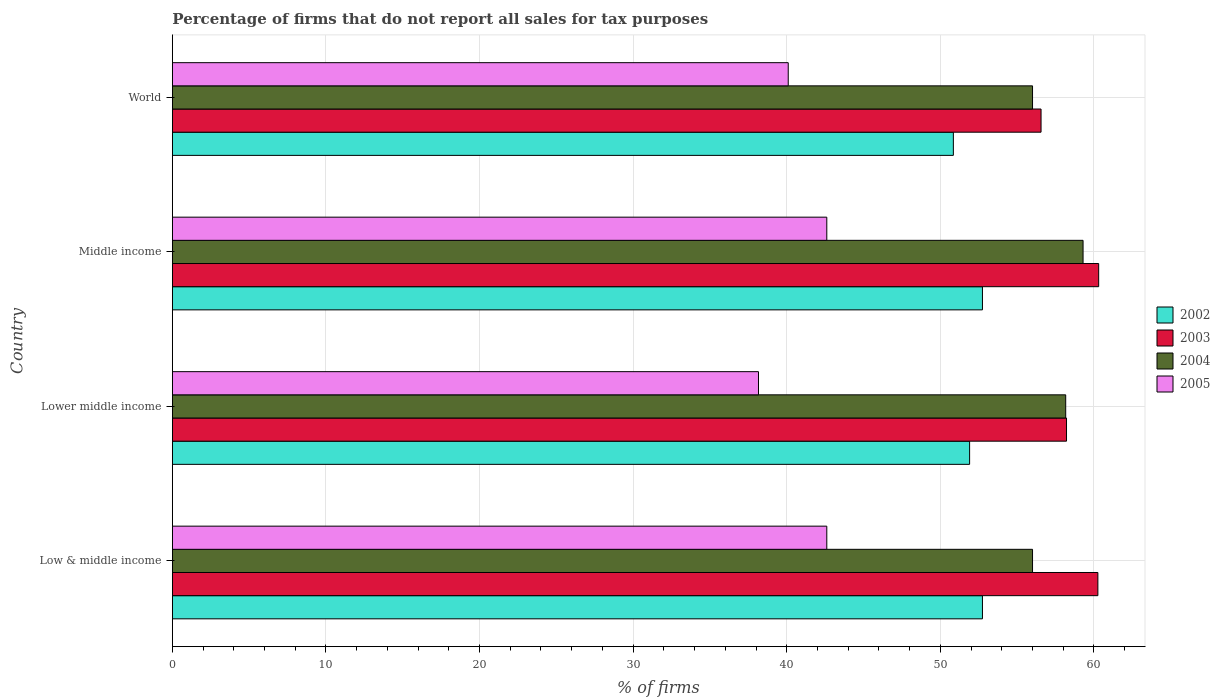How many different coloured bars are there?
Offer a terse response. 4. How many bars are there on the 4th tick from the top?
Keep it short and to the point. 4. What is the percentage of firms that do not report all sales for tax purposes in 2005 in Low & middle income?
Provide a short and direct response. 42.61. Across all countries, what is the maximum percentage of firms that do not report all sales for tax purposes in 2003?
Your response must be concise. 60.31. Across all countries, what is the minimum percentage of firms that do not report all sales for tax purposes in 2005?
Offer a terse response. 38.16. In which country was the percentage of firms that do not report all sales for tax purposes in 2005 minimum?
Offer a very short reply. Lower middle income. What is the total percentage of firms that do not report all sales for tax purposes in 2005 in the graph?
Provide a succinct answer. 163.48. What is the difference between the percentage of firms that do not report all sales for tax purposes in 2004 in Low & middle income and that in Lower middle income?
Keep it short and to the point. -2.16. What is the difference between the percentage of firms that do not report all sales for tax purposes in 2004 in Middle income and the percentage of firms that do not report all sales for tax purposes in 2002 in Low & middle income?
Provide a succinct answer. 6.55. What is the average percentage of firms that do not report all sales for tax purposes in 2002 per country?
Make the answer very short. 52.06. What is the difference between the percentage of firms that do not report all sales for tax purposes in 2004 and percentage of firms that do not report all sales for tax purposes in 2005 in Middle income?
Provide a succinct answer. 16.69. What is the ratio of the percentage of firms that do not report all sales for tax purposes in 2004 in Lower middle income to that in World?
Your answer should be very brief. 1.04. What is the difference between the highest and the second highest percentage of firms that do not report all sales for tax purposes in 2002?
Give a very brief answer. 0. What is the difference between the highest and the lowest percentage of firms that do not report all sales for tax purposes in 2004?
Your answer should be compact. 3.29. What does the 3rd bar from the top in Lower middle income represents?
Provide a short and direct response. 2003. What does the 3rd bar from the bottom in Lower middle income represents?
Make the answer very short. 2004. How many bars are there?
Make the answer very short. 16. Are all the bars in the graph horizontal?
Offer a terse response. Yes. Are the values on the major ticks of X-axis written in scientific E-notation?
Provide a short and direct response. No. Does the graph contain any zero values?
Keep it short and to the point. No. What is the title of the graph?
Your answer should be compact. Percentage of firms that do not report all sales for tax purposes. Does "1968" appear as one of the legend labels in the graph?
Provide a short and direct response. No. What is the label or title of the X-axis?
Keep it short and to the point. % of firms. What is the label or title of the Y-axis?
Make the answer very short. Country. What is the % of firms of 2002 in Low & middle income?
Keep it short and to the point. 52.75. What is the % of firms in 2003 in Low & middle income?
Your answer should be very brief. 60.26. What is the % of firms of 2004 in Low & middle income?
Your response must be concise. 56.01. What is the % of firms in 2005 in Low & middle income?
Your answer should be very brief. 42.61. What is the % of firms of 2002 in Lower middle income?
Offer a terse response. 51.91. What is the % of firms in 2003 in Lower middle income?
Offer a very short reply. 58.22. What is the % of firms of 2004 in Lower middle income?
Your response must be concise. 58.16. What is the % of firms of 2005 in Lower middle income?
Ensure brevity in your answer.  38.16. What is the % of firms of 2002 in Middle income?
Keep it short and to the point. 52.75. What is the % of firms in 2003 in Middle income?
Your answer should be very brief. 60.31. What is the % of firms in 2004 in Middle income?
Your response must be concise. 59.3. What is the % of firms in 2005 in Middle income?
Ensure brevity in your answer.  42.61. What is the % of firms in 2002 in World?
Offer a very short reply. 50.85. What is the % of firms of 2003 in World?
Provide a short and direct response. 56.56. What is the % of firms in 2004 in World?
Offer a very short reply. 56.01. What is the % of firms of 2005 in World?
Provide a succinct answer. 40.1. Across all countries, what is the maximum % of firms of 2002?
Your answer should be very brief. 52.75. Across all countries, what is the maximum % of firms of 2003?
Give a very brief answer. 60.31. Across all countries, what is the maximum % of firms in 2004?
Give a very brief answer. 59.3. Across all countries, what is the maximum % of firms in 2005?
Give a very brief answer. 42.61. Across all countries, what is the minimum % of firms of 2002?
Give a very brief answer. 50.85. Across all countries, what is the minimum % of firms in 2003?
Offer a very short reply. 56.56. Across all countries, what is the minimum % of firms of 2004?
Make the answer very short. 56.01. Across all countries, what is the minimum % of firms of 2005?
Give a very brief answer. 38.16. What is the total % of firms in 2002 in the graph?
Keep it short and to the point. 208.25. What is the total % of firms of 2003 in the graph?
Your answer should be compact. 235.35. What is the total % of firms of 2004 in the graph?
Your answer should be very brief. 229.47. What is the total % of firms in 2005 in the graph?
Give a very brief answer. 163.48. What is the difference between the % of firms of 2002 in Low & middle income and that in Lower middle income?
Your answer should be very brief. 0.84. What is the difference between the % of firms in 2003 in Low & middle income and that in Lower middle income?
Keep it short and to the point. 2.04. What is the difference between the % of firms of 2004 in Low & middle income and that in Lower middle income?
Provide a succinct answer. -2.16. What is the difference between the % of firms in 2005 in Low & middle income and that in Lower middle income?
Your answer should be very brief. 4.45. What is the difference between the % of firms of 2003 in Low & middle income and that in Middle income?
Your answer should be very brief. -0.05. What is the difference between the % of firms of 2004 in Low & middle income and that in Middle income?
Your answer should be very brief. -3.29. What is the difference between the % of firms in 2005 in Low & middle income and that in Middle income?
Offer a very short reply. 0. What is the difference between the % of firms of 2002 in Low & middle income and that in World?
Your answer should be very brief. 1.89. What is the difference between the % of firms of 2004 in Low & middle income and that in World?
Provide a succinct answer. 0. What is the difference between the % of firms in 2005 in Low & middle income and that in World?
Provide a succinct answer. 2.51. What is the difference between the % of firms in 2002 in Lower middle income and that in Middle income?
Your answer should be very brief. -0.84. What is the difference between the % of firms of 2003 in Lower middle income and that in Middle income?
Give a very brief answer. -2.09. What is the difference between the % of firms in 2004 in Lower middle income and that in Middle income?
Your answer should be very brief. -1.13. What is the difference between the % of firms of 2005 in Lower middle income and that in Middle income?
Your answer should be very brief. -4.45. What is the difference between the % of firms of 2002 in Lower middle income and that in World?
Your answer should be very brief. 1.06. What is the difference between the % of firms of 2003 in Lower middle income and that in World?
Offer a terse response. 1.66. What is the difference between the % of firms of 2004 in Lower middle income and that in World?
Make the answer very short. 2.16. What is the difference between the % of firms in 2005 in Lower middle income and that in World?
Your answer should be very brief. -1.94. What is the difference between the % of firms of 2002 in Middle income and that in World?
Your response must be concise. 1.89. What is the difference between the % of firms in 2003 in Middle income and that in World?
Provide a short and direct response. 3.75. What is the difference between the % of firms of 2004 in Middle income and that in World?
Provide a short and direct response. 3.29. What is the difference between the % of firms of 2005 in Middle income and that in World?
Ensure brevity in your answer.  2.51. What is the difference between the % of firms of 2002 in Low & middle income and the % of firms of 2003 in Lower middle income?
Your response must be concise. -5.47. What is the difference between the % of firms of 2002 in Low & middle income and the % of firms of 2004 in Lower middle income?
Provide a succinct answer. -5.42. What is the difference between the % of firms of 2002 in Low & middle income and the % of firms of 2005 in Lower middle income?
Ensure brevity in your answer.  14.58. What is the difference between the % of firms in 2003 in Low & middle income and the % of firms in 2004 in Lower middle income?
Ensure brevity in your answer.  2.1. What is the difference between the % of firms in 2003 in Low & middle income and the % of firms in 2005 in Lower middle income?
Offer a very short reply. 22.1. What is the difference between the % of firms of 2004 in Low & middle income and the % of firms of 2005 in Lower middle income?
Your response must be concise. 17.84. What is the difference between the % of firms of 2002 in Low & middle income and the % of firms of 2003 in Middle income?
Your answer should be compact. -7.57. What is the difference between the % of firms in 2002 in Low & middle income and the % of firms in 2004 in Middle income?
Offer a very short reply. -6.55. What is the difference between the % of firms of 2002 in Low & middle income and the % of firms of 2005 in Middle income?
Provide a succinct answer. 10.13. What is the difference between the % of firms of 2003 in Low & middle income and the % of firms of 2004 in Middle income?
Offer a very short reply. 0.96. What is the difference between the % of firms in 2003 in Low & middle income and the % of firms in 2005 in Middle income?
Offer a terse response. 17.65. What is the difference between the % of firms in 2004 in Low & middle income and the % of firms in 2005 in Middle income?
Keep it short and to the point. 13.39. What is the difference between the % of firms of 2002 in Low & middle income and the % of firms of 2003 in World?
Offer a terse response. -3.81. What is the difference between the % of firms in 2002 in Low & middle income and the % of firms in 2004 in World?
Your answer should be very brief. -3.26. What is the difference between the % of firms of 2002 in Low & middle income and the % of firms of 2005 in World?
Make the answer very short. 12.65. What is the difference between the % of firms of 2003 in Low & middle income and the % of firms of 2004 in World?
Offer a terse response. 4.25. What is the difference between the % of firms in 2003 in Low & middle income and the % of firms in 2005 in World?
Make the answer very short. 20.16. What is the difference between the % of firms in 2004 in Low & middle income and the % of firms in 2005 in World?
Make the answer very short. 15.91. What is the difference between the % of firms in 2002 in Lower middle income and the % of firms in 2003 in Middle income?
Ensure brevity in your answer.  -8.4. What is the difference between the % of firms in 2002 in Lower middle income and the % of firms in 2004 in Middle income?
Ensure brevity in your answer.  -7.39. What is the difference between the % of firms in 2002 in Lower middle income and the % of firms in 2005 in Middle income?
Give a very brief answer. 9.3. What is the difference between the % of firms of 2003 in Lower middle income and the % of firms of 2004 in Middle income?
Provide a succinct answer. -1.08. What is the difference between the % of firms in 2003 in Lower middle income and the % of firms in 2005 in Middle income?
Offer a terse response. 15.61. What is the difference between the % of firms in 2004 in Lower middle income and the % of firms in 2005 in Middle income?
Keep it short and to the point. 15.55. What is the difference between the % of firms of 2002 in Lower middle income and the % of firms of 2003 in World?
Provide a short and direct response. -4.65. What is the difference between the % of firms in 2002 in Lower middle income and the % of firms in 2004 in World?
Keep it short and to the point. -4.1. What is the difference between the % of firms of 2002 in Lower middle income and the % of firms of 2005 in World?
Your response must be concise. 11.81. What is the difference between the % of firms in 2003 in Lower middle income and the % of firms in 2004 in World?
Provide a succinct answer. 2.21. What is the difference between the % of firms in 2003 in Lower middle income and the % of firms in 2005 in World?
Ensure brevity in your answer.  18.12. What is the difference between the % of firms in 2004 in Lower middle income and the % of firms in 2005 in World?
Your response must be concise. 18.07. What is the difference between the % of firms in 2002 in Middle income and the % of firms in 2003 in World?
Provide a succinct answer. -3.81. What is the difference between the % of firms in 2002 in Middle income and the % of firms in 2004 in World?
Make the answer very short. -3.26. What is the difference between the % of firms of 2002 in Middle income and the % of firms of 2005 in World?
Your response must be concise. 12.65. What is the difference between the % of firms of 2003 in Middle income and the % of firms of 2004 in World?
Ensure brevity in your answer.  4.31. What is the difference between the % of firms of 2003 in Middle income and the % of firms of 2005 in World?
Make the answer very short. 20.21. What is the difference between the % of firms of 2004 in Middle income and the % of firms of 2005 in World?
Keep it short and to the point. 19.2. What is the average % of firms of 2002 per country?
Your response must be concise. 52.06. What is the average % of firms of 2003 per country?
Your response must be concise. 58.84. What is the average % of firms of 2004 per country?
Provide a short and direct response. 57.37. What is the average % of firms of 2005 per country?
Provide a succinct answer. 40.87. What is the difference between the % of firms in 2002 and % of firms in 2003 in Low & middle income?
Keep it short and to the point. -7.51. What is the difference between the % of firms in 2002 and % of firms in 2004 in Low & middle income?
Keep it short and to the point. -3.26. What is the difference between the % of firms of 2002 and % of firms of 2005 in Low & middle income?
Ensure brevity in your answer.  10.13. What is the difference between the % of firms in 2003 and % of firms in 2004 in Low & middle income?
Offer a very short reply. 4.25. What is the difference between the % of firms in 2003 and % of firms in 2005 in Low & middle income?
Keep it short and to the point. 17.65. What is the difference between the % of firms of 2004 and % of firms of 2005 in Low & middle income?
Your answer should be compact. 13.39. What is the difference between the % of firms of 2002 and % of firms of 2003 in Lower middle income?
Make the answer very short. -6.31. What is the difference between the % of firms in 2002 and % of firms in 2004 in Lower middle income?
Provide a succinct answer. -6.26. What is the difference between the % of firms in 2002 and % of firms in 2005 in Lower middle income?
Offer a very short reply. 13.75. What is the difference between the % of firms of 2003 and % of firms of 2004 in Lower middle income?
Offer a very short reply. 0.05. What is the difference between the % of firms in 2003 and % of firms in 2005 in Lower middle income?
Offer a very short reply. 20.06. What is the difference between the % of firms of 2004 and % of firms of 2005 in Lower middle income?
Offer a terse response. 20. What is the difference between the % of firms in 2002 and % of firms in 2003 in Middle income?
Make the answer very short. -7.57. What is the difference between the % of firms in 2002 and % of firms in 2004 in Middle income?
Your answer should be very brief. -6.55. What is the difference between the % of firms in 2002 and % of firms in 2005 in Middle income?
Offer a terse response. 10.13. What is the difference between the % of firms of 2003 and % of firms of 2004 in Middle income?
Your response must be concise. 1.02. What is the difference between the % of firms in 2003 and % of firms in 2005 in Middle income?
Provide a short and direct response. 17.7. What is the difference between the % of firms in 2004 and % of firms in 2005 in Middle income?
Offer a very short reply. 16.69. What is the difference between the % of firms of 2002 and % of firms of 2003 in World?
Offer a terse response. -5.71. What is the difference between the % of firms in 2002 and % of firms in 2004 in World?
Offer a terse response. -5.15. What is the difference between the % of firms in 2002 and % of firms in 2005 in World?
Make the answer very short. 10.75. What is the difference between the % of firms of 2003 and % of firms of 2004 in World?
Ensure brevity in your answer.  0.56. What is the difference between the % of firms of 2003 and % of firms of 2005 in World?
Make the answer very short. 16.46. What is the difference between the % of firms of 2004 and % of firms of 2005 in World?
Offer a very short reply. 15.91. What is the ratio of the % of firms of 2002 in Low & middle income to that in Lower middle income?
Your answer should be compact. 1.02. What is the ratio of the % of firms in 2003 in Low & middle income to that in Lower middle income?
Your answer should be very brief. 1.04. What is the ratio of the % of firms of 2004 in Low & middle income to that in Lower middle income?
Make the answer very short. 0.96. What is the ratio of the % of firms of 2005 in Low & middle income to that in Lower middle income?
Provide a succinct answer. 1.12. What is the ratio of the % of firms of 2003 in Low & middle income to that in Middle income?
Keep it short and to the point. 1. What is the ratio of the % of firms of 2004 in Low & middle income to that in Middle income?
Provide a succinct answer. 0.94. What is the ratio of the % of firms of 2005 in Low & middle income to that in Middle income?
Ensure brevity in your answer.  1. What is the ratio of the % of firms of 2002 in Low & middle income to that in World?
Ensure brevity in your answer.  1.04. What is the ratio of the % of firms in 2003 in Low & middle income to that in World?
Keep it short and to the point. 1.07. What is the ratio of the % of firms of 2004 in Low & middle income to that in World?
Provide a succinct answer. 1. What is the ratio of the % of firms in 2005 in Low & middle income to that in World?
Ensure brevity in your answer.  1.06. What is the ratio of the % of firms of 2002 in Lower middle income to that in Middle income?
Your response must be concise. 0.98. What is the ratio of the % of firms of 2003 in Lower middle income to that in Middle income?
Ensure brevity in your answer.  0.97. What is the ratio of the % of firms of 2004 in Lower middle income to that in Middle income?
Give a very brief answer. 0.98. What is the ratio of the % of firms in 2005 in Lower middle income to that in Middle income?
Your response must be concise. 0.9. What is the ratio of the % of firms of 2002 in Lower middle income to that in World?
Provide a short and direct response. 1.02. What is the ratio of the % of firms of 2003 in Lower middle income to that in World?
Your answer should be compact. 1.03. What is the ratio of the % of firms of 2004 in Lower middle income to that in World?
Provide a short and direct response. 1.04. What is the ratio of the % of firms of 2005 in Lower middle income to that in World?
Your answer should be compact. 0.95. What is the ratio of the % of firms of 2002 in Middle income to that in World?
Your answer should be compact. 1.04. What is the ratio of the % of firms in 2003 in Middle income to that in World?
Make the answer very short. 1.07. What is the ratio of the % of firms of 2004 in Middle income to that in World?
Provide a succinct answer. 1.06. What is the ratio of the % of firms of 2005 in Middle income to that in World?
Ensure brevity in your answer.  1.06. What is the difference between the highest and the second highest % of firms in 2003?
Offer a terse response. 0.05. What is the difference between the highest and the second highest % of firms in 2004?
Provide a succinct answer. 1.13. What is the difference between the highest and the lowest % of firms in 2002?
Give a very brief answer. 1.89. What is the difference between the highest and the lowest % of firms in 2003?
Offer a very short reply. 3.75. What is the difference between the highest and the lowest % of firms in 2004?
Ensure brevity in your answer.  3.29. What is the difference between the highest and the lowest % of firms in 2005?
Offer a very short reply. 4.45. 